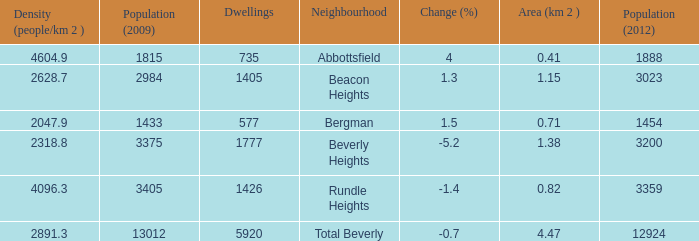How many Dwellings does Beverly Heights have that have a change percent larger than -5.2? None. 